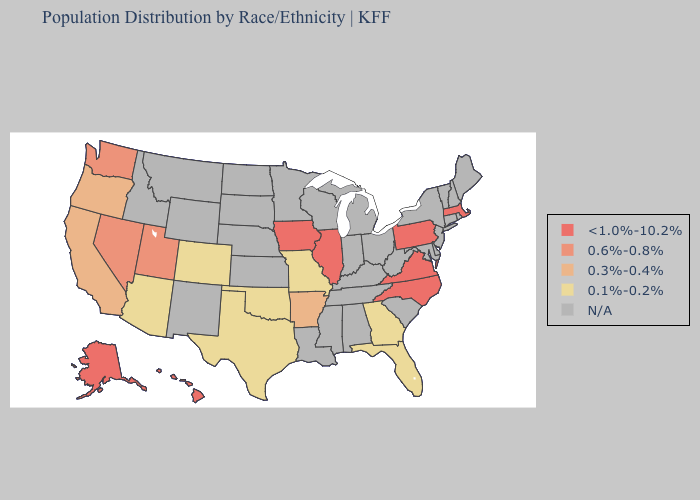Among the states that border Louisiana , does Arkansas have the lowest value?
Answer briefly. No. Name the states that have a value in the range 0.3%-0.4%?
Give a very brief answer. Arkansas, California, Oregon. Name the states that have a value in the range 0.6%-0.8%?
Give a very brief answer. Nevada, Utah, Washington. Which states have the lowest value in the South?
Answer briefly. Florida, Georgia, Oklahoma, Texas. Name the states that have a value in the range N/A?
Answer briefly. Alabama, Connecticut, Delaware, Idaho, Indiana, Kansas, Kentucky, Louisiana, Maine, Maryland, Michigan, Minnesota, Mississippi, Montana, Nebraska, New Hampshire, New Jersey, New Mexico, New York, North Dakota, Ohio, Rhode Island, South Carolina, South Dakota, Tennessee, Vermont, West Virginia, Wisconsin, Wyoming. What is the value of New Jersey?
Concise answer only. N/A. Is the legend a continuous bar?
Be succinct. No. Name the states that have a value in the range <1.0%-10.2%?
Short answer required. Alaska, Hawaii, Illinois, Iowa, Massachusetts, North Carolina, Pennsylvania, Virginia. Does the first symbol in the legend represent the smallest category?
Short answer required. No. Among the states that border Texas , which have the highest value?
Answer briefly. Arkansas. Which states have the lowest value in the USA?
Quick response, please. Arizona, Colorado, Florida, Georgia, Missouri, Oklahoma, Texas. What is the value of New Jersey?
Write a very short answer. N/A. 